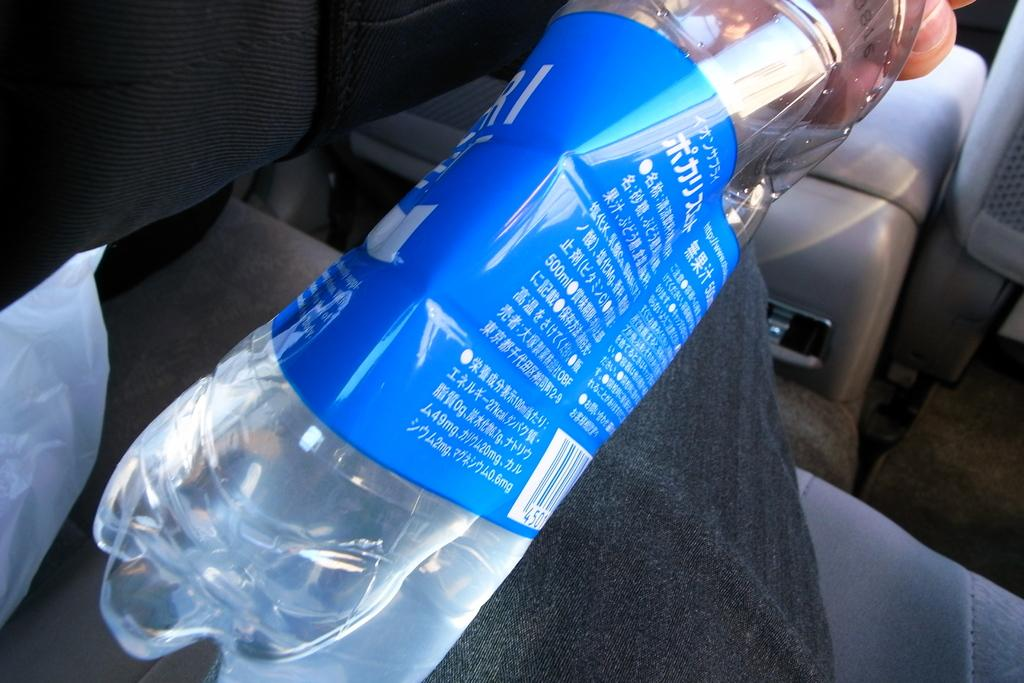What is the person in the image holding? The person is holding a bottle. What else can be seen in the image besides the person? There is a cover and a seat in the image. What type of advertisement can be seen in the image? There is no advertisement present in the image. Is the person in the image on vacation? There is no information about the person's vacation status in the image. 